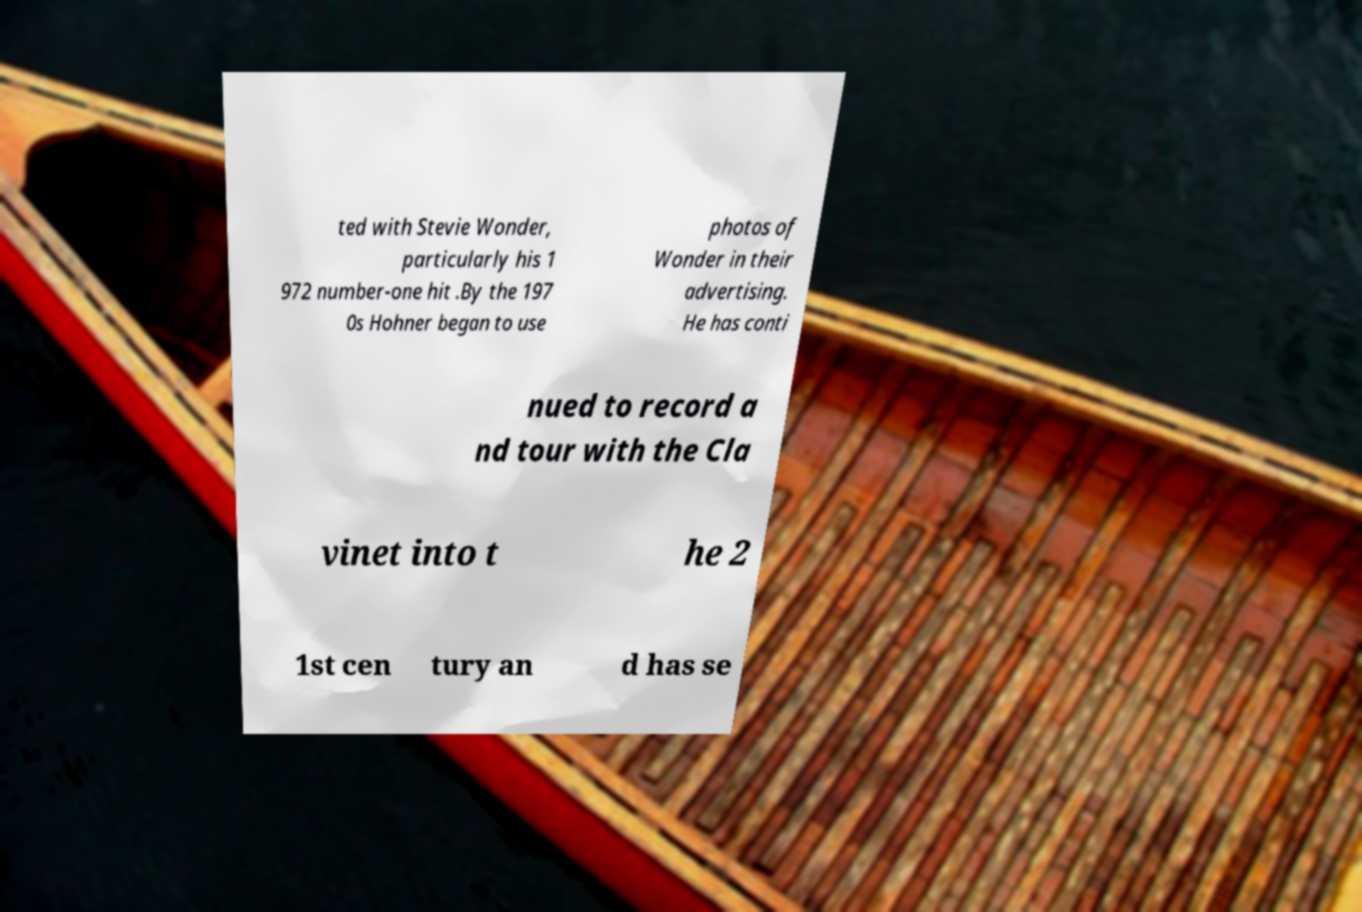There's text embedded in this image that I need extracted. Can you transcribe it verbatim? ted with Stevie Wonder, particularly his 1 972 number-one hit .By the 197 0s Hohner began to use photos of Wonder in their advertising. He has conti nued to record a nd tour with the Cla vinet into t he 2 1st cen tury an d has se 